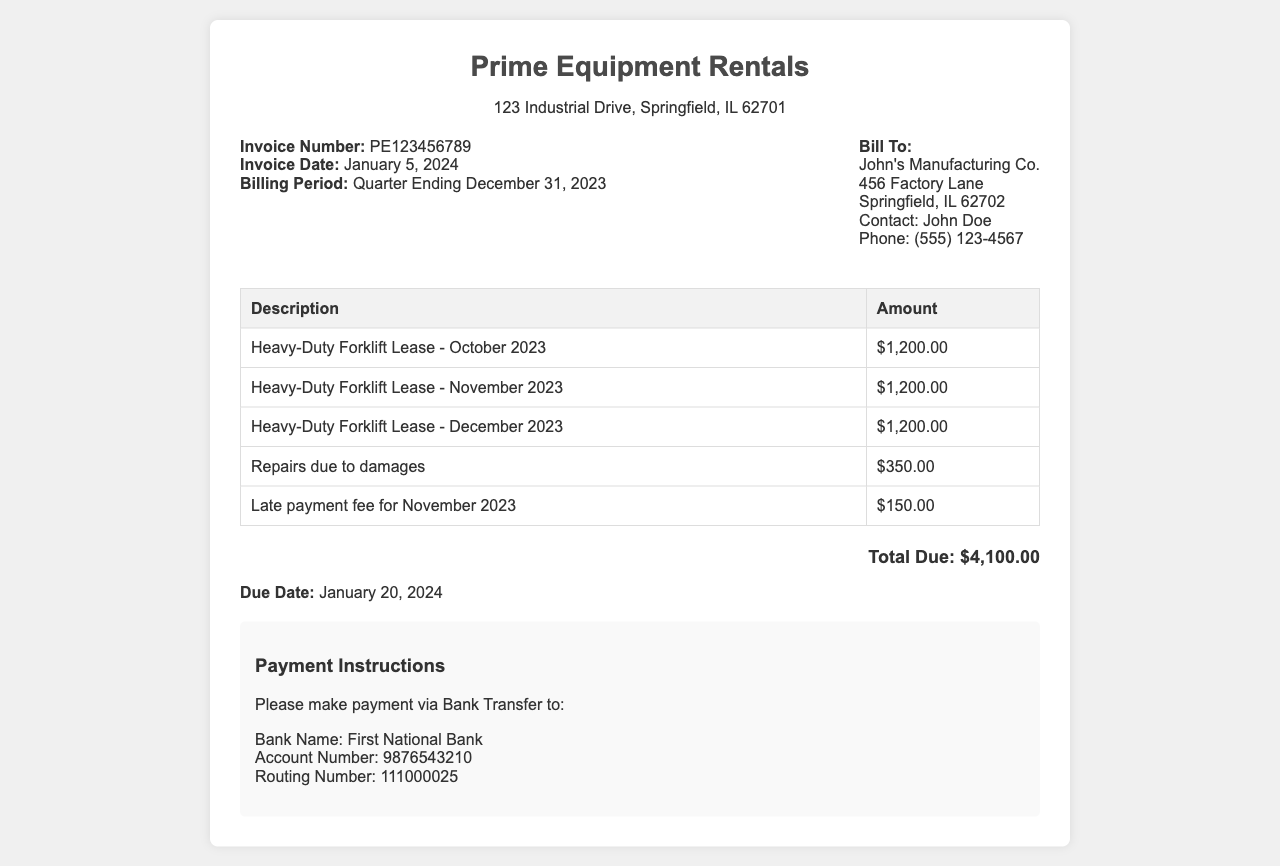What is the invoice number? The invoice number is listed in the document as a specific identifier for this invoice.
Answer: PE123456789 What is the due date for the payment? The due date is provided in the document to inform when the payment should be made.
Answer: January 20, 2024 How much is the monthly fee for the forklift lease? The monthly fee for the forklift lease is repeated for each month and is provided in the invoice details.
Answer: $1,200.00 What is the total amount due? The total amount due is calculated from the sum of all charges listed in the invoice.
Answer: $4,100.00 What additional charge is included for repairs? The document specifies any additional charges that may apply, including damages.
Answer: $350.00 What is the late payment fee for November 2023? This fee is specifically mentioned to highlight the consequence of late payment.
Answer: $150.00 Which company is being billed? This information identifies the customer in the invoice for clear billing purposes.
Answer: John's Manufacturing Co What is the billing period for this invoice? The billing period defines the timeframe for which the leasing service is being billed.
Answer: Quarter Ending December 31, 2023 Who should payments be made to? This specifies the recipient for the payment to ensure proper processing.
Answer: First National Bank 